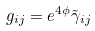Convert formula to latex. <formula><loc_0><loc_0><loc_500><loc_500>g _ { i j } = e ^ { 4 \phi } \tilde { \gamma } _ { i j }</formula> 